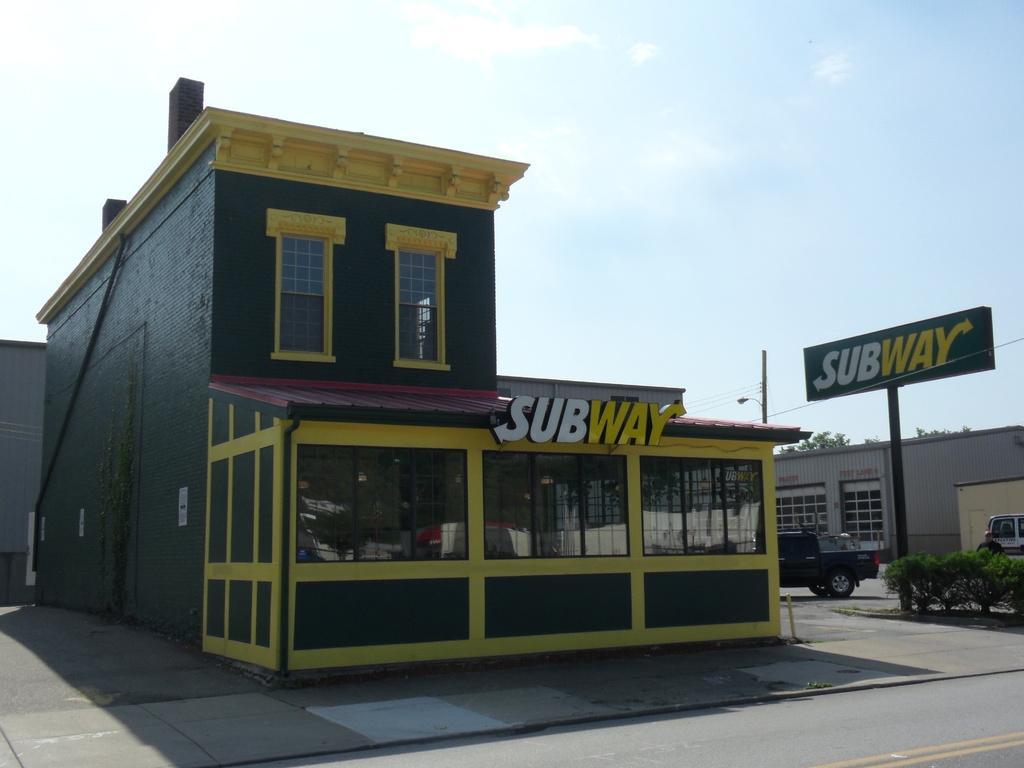Please provide a concise description of this image. In this picture we can see few buildings and hoardings, and also we can see few shrubs, trees, pole and vehicles. 